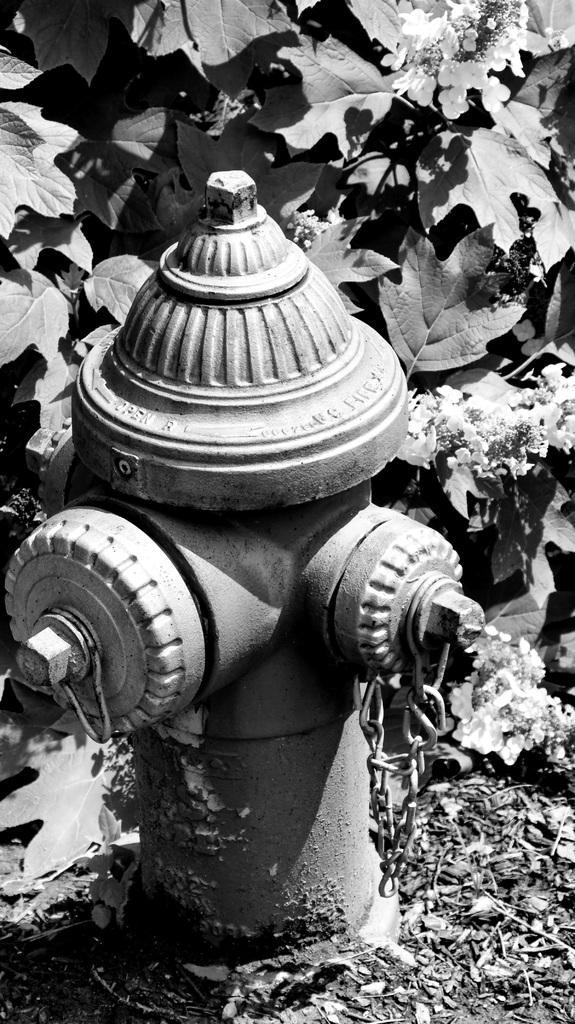Describe this image in one or two sentences. It is a black and white picture. In the center of the image we can see a standpipe with a chain. In the background, we can see leaves and flowers. 